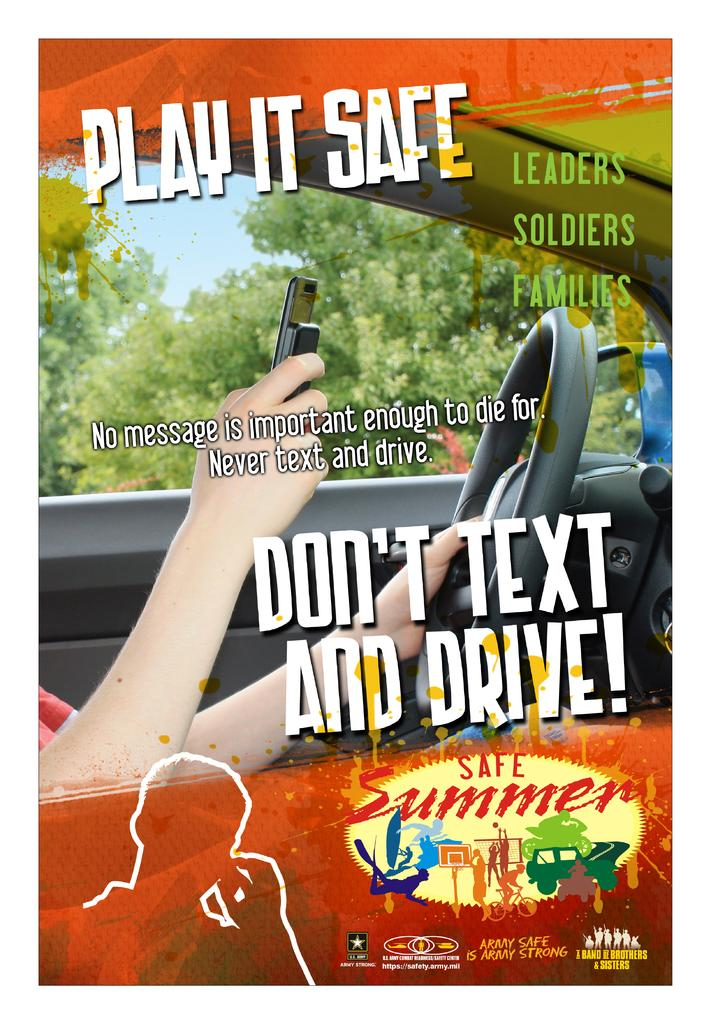What can be seen in the background of the image? The sky is visible in the image, along with trees. What is the person inside the car doing? The person is holding a mobile and a steering wheel. What might the person be using the mobile for? The person might be using the mobile for communication or navigation while driving. Can you describe the information visible in the image? The information visible in the image is related to the car, such as speed, distance, or directions. How many zebras can be seen grazing near the trees in the image? There are no zebras present in the image; it features a person inside a car with trees and the sky visible in the background. 